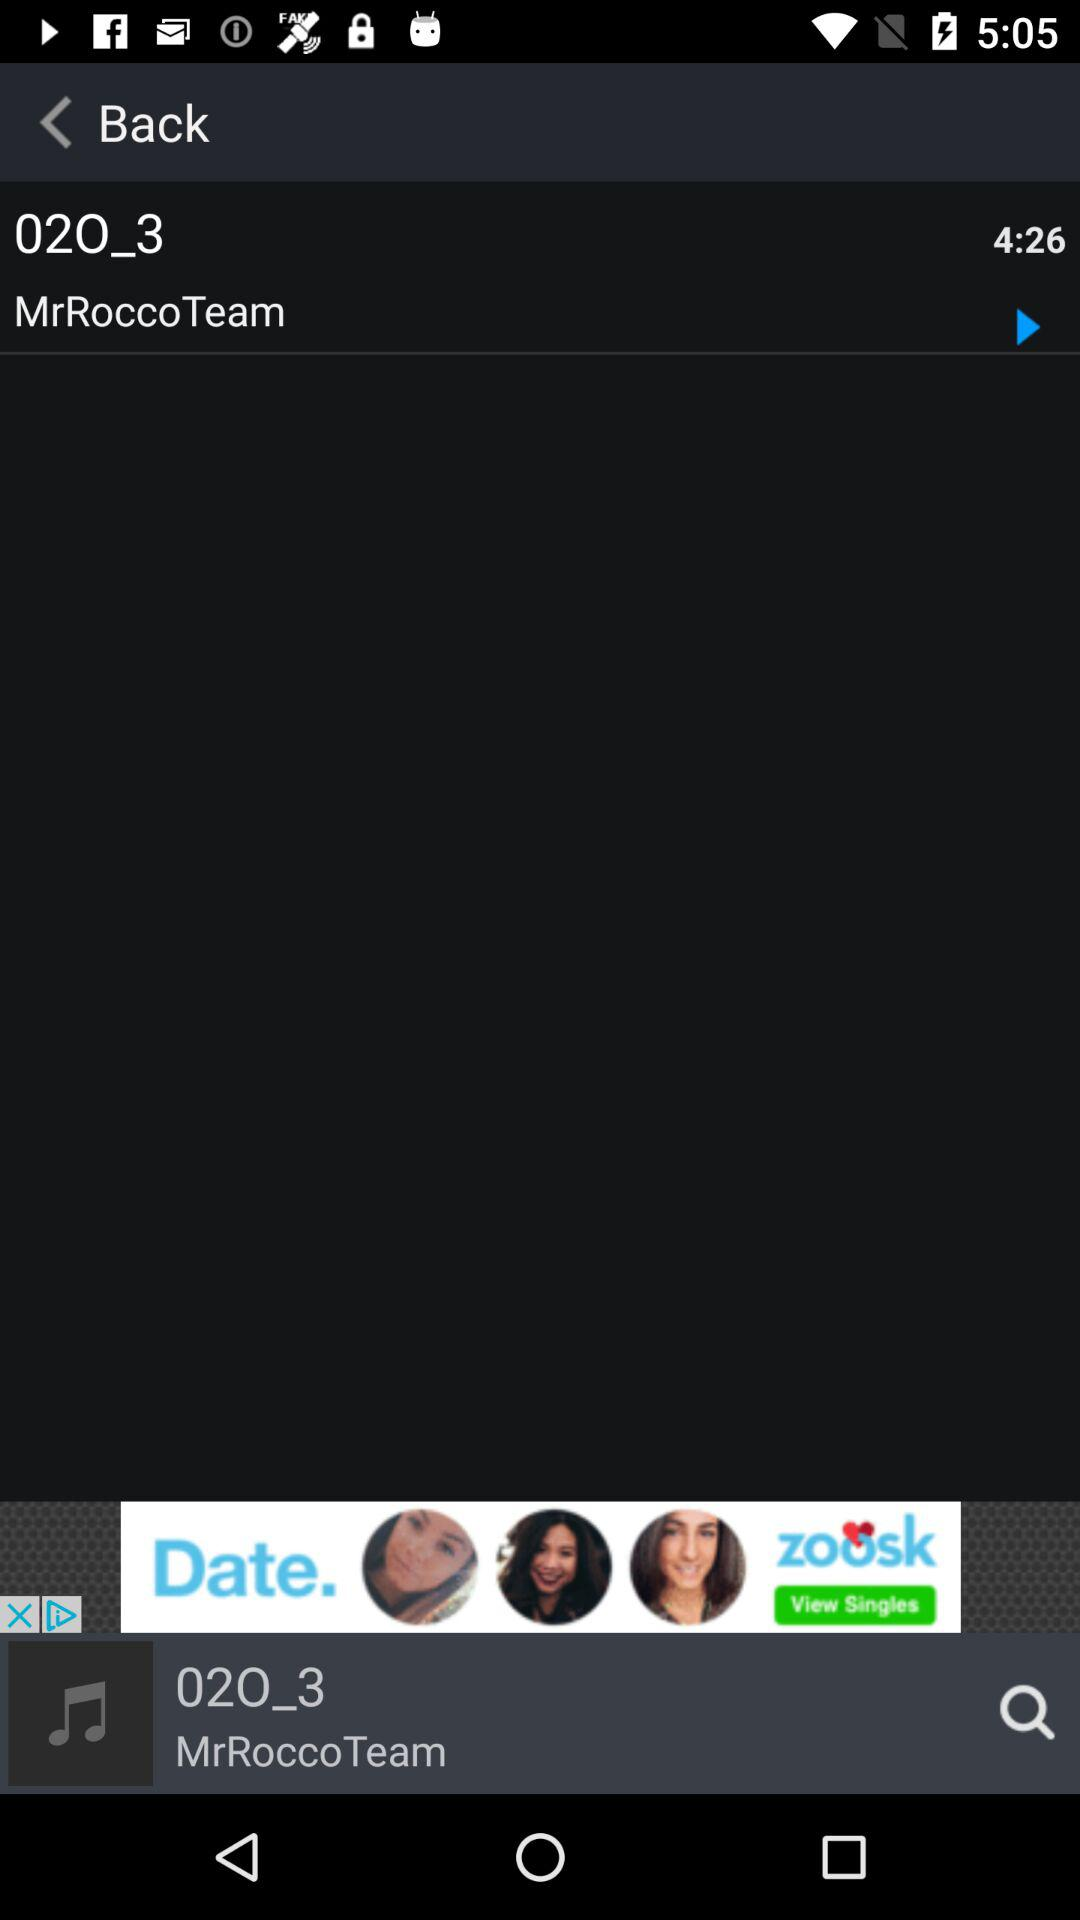Who is the artist of the song? The artist of the song is MrRoccoTeam. 